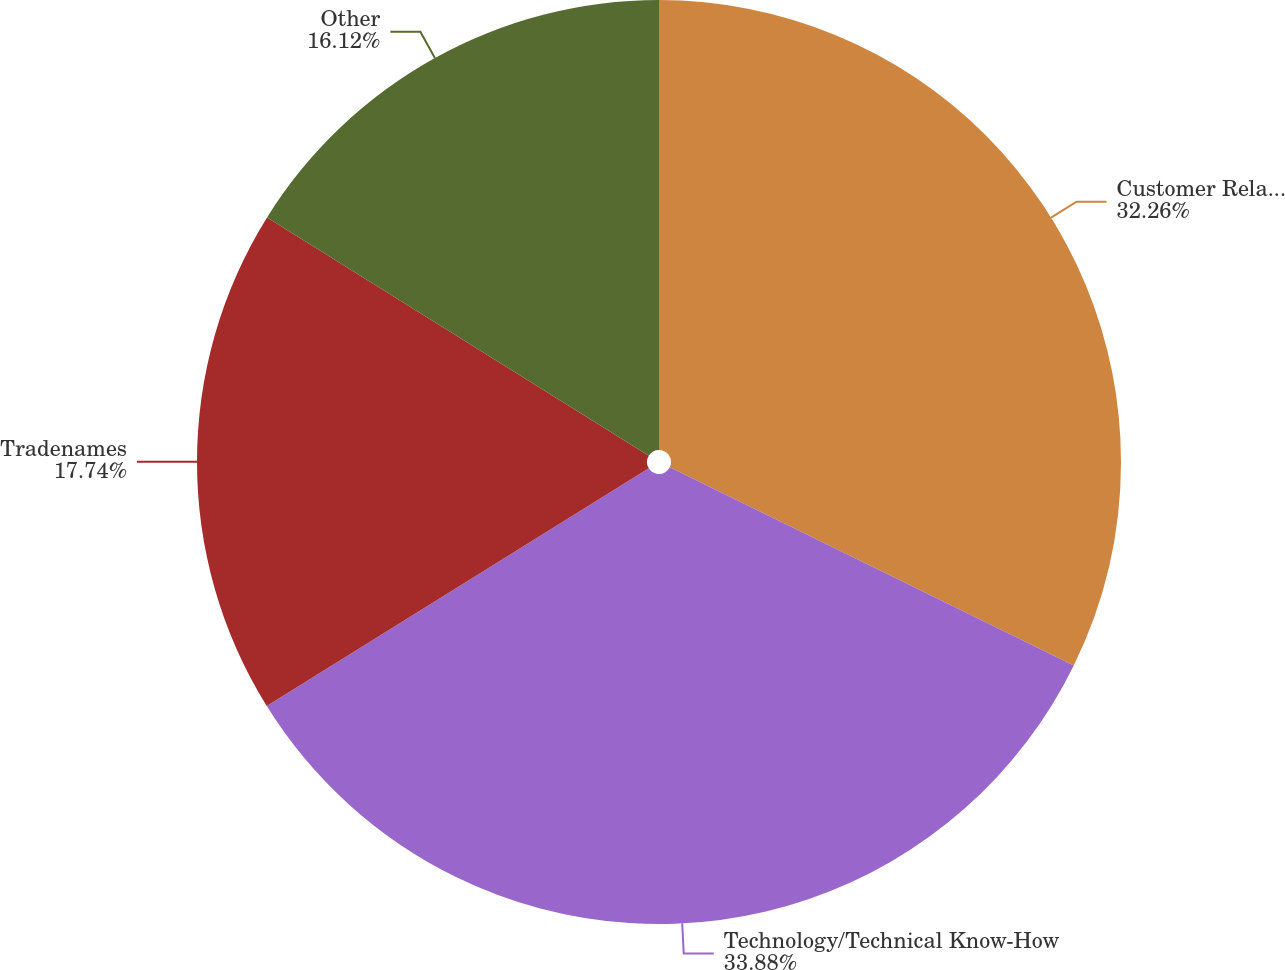<chart> <loc_0><loc_0><loc_500><loc_500><pie_chart><fcel>Customer Relationships<fcel>Technology/Technical Know-How<fcel>Tradenames<fcel>Other<nl><fcel>32.26%<fcel>33.88%<fcel>17.74%<fcel>16.12%<nl></chart> 